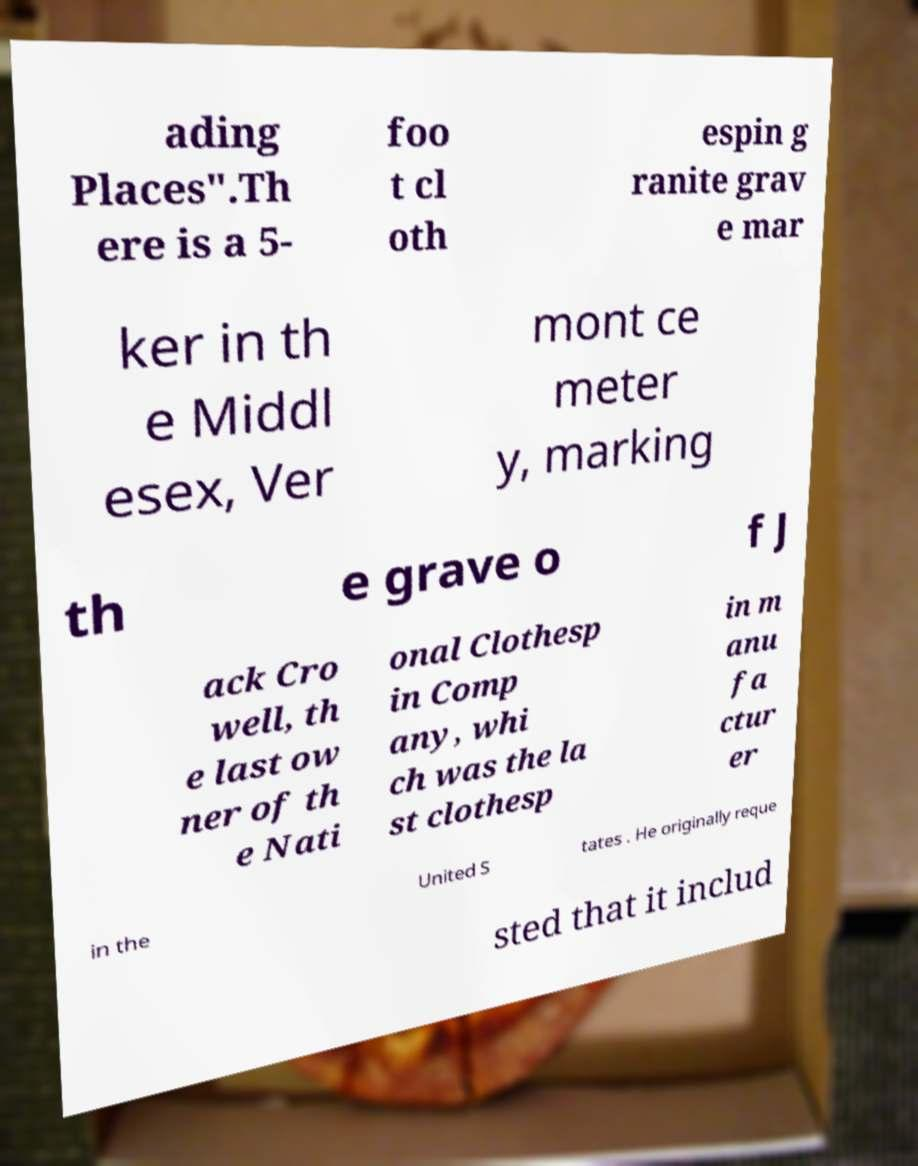There's text embedded in this image that I need extracted. Can you transcribe it verbatim? ading Places".Th ere is a 5- foo t cl oth espin g ranite grav e mar ker in th e Middl esex, Ver mont ce meter y, marking th e grave o f J ack Cro well, th e last ow ner of th e Nati onal Clothesp in Comp any, whi ch was the la st clothesp in m anu fa ctur er in the United S tates . He originally reque sted that it includ 